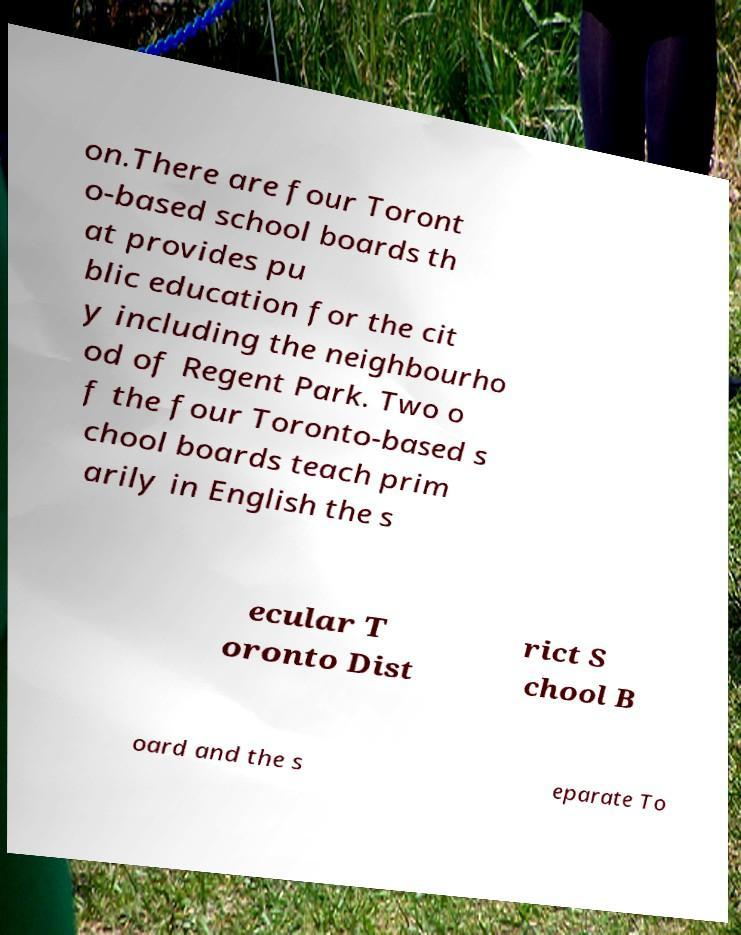Can you accurately transcribe the text from the provided image for me? on.There are four Toront o-based school boards th at provides pu blic education for the cit y including the neighbourho od of Regent Park. Two o f the four Toronto-based s chool boards teach prim arily in English the s ecular T oronto Dist rict S chool B oard and the s eparate To 